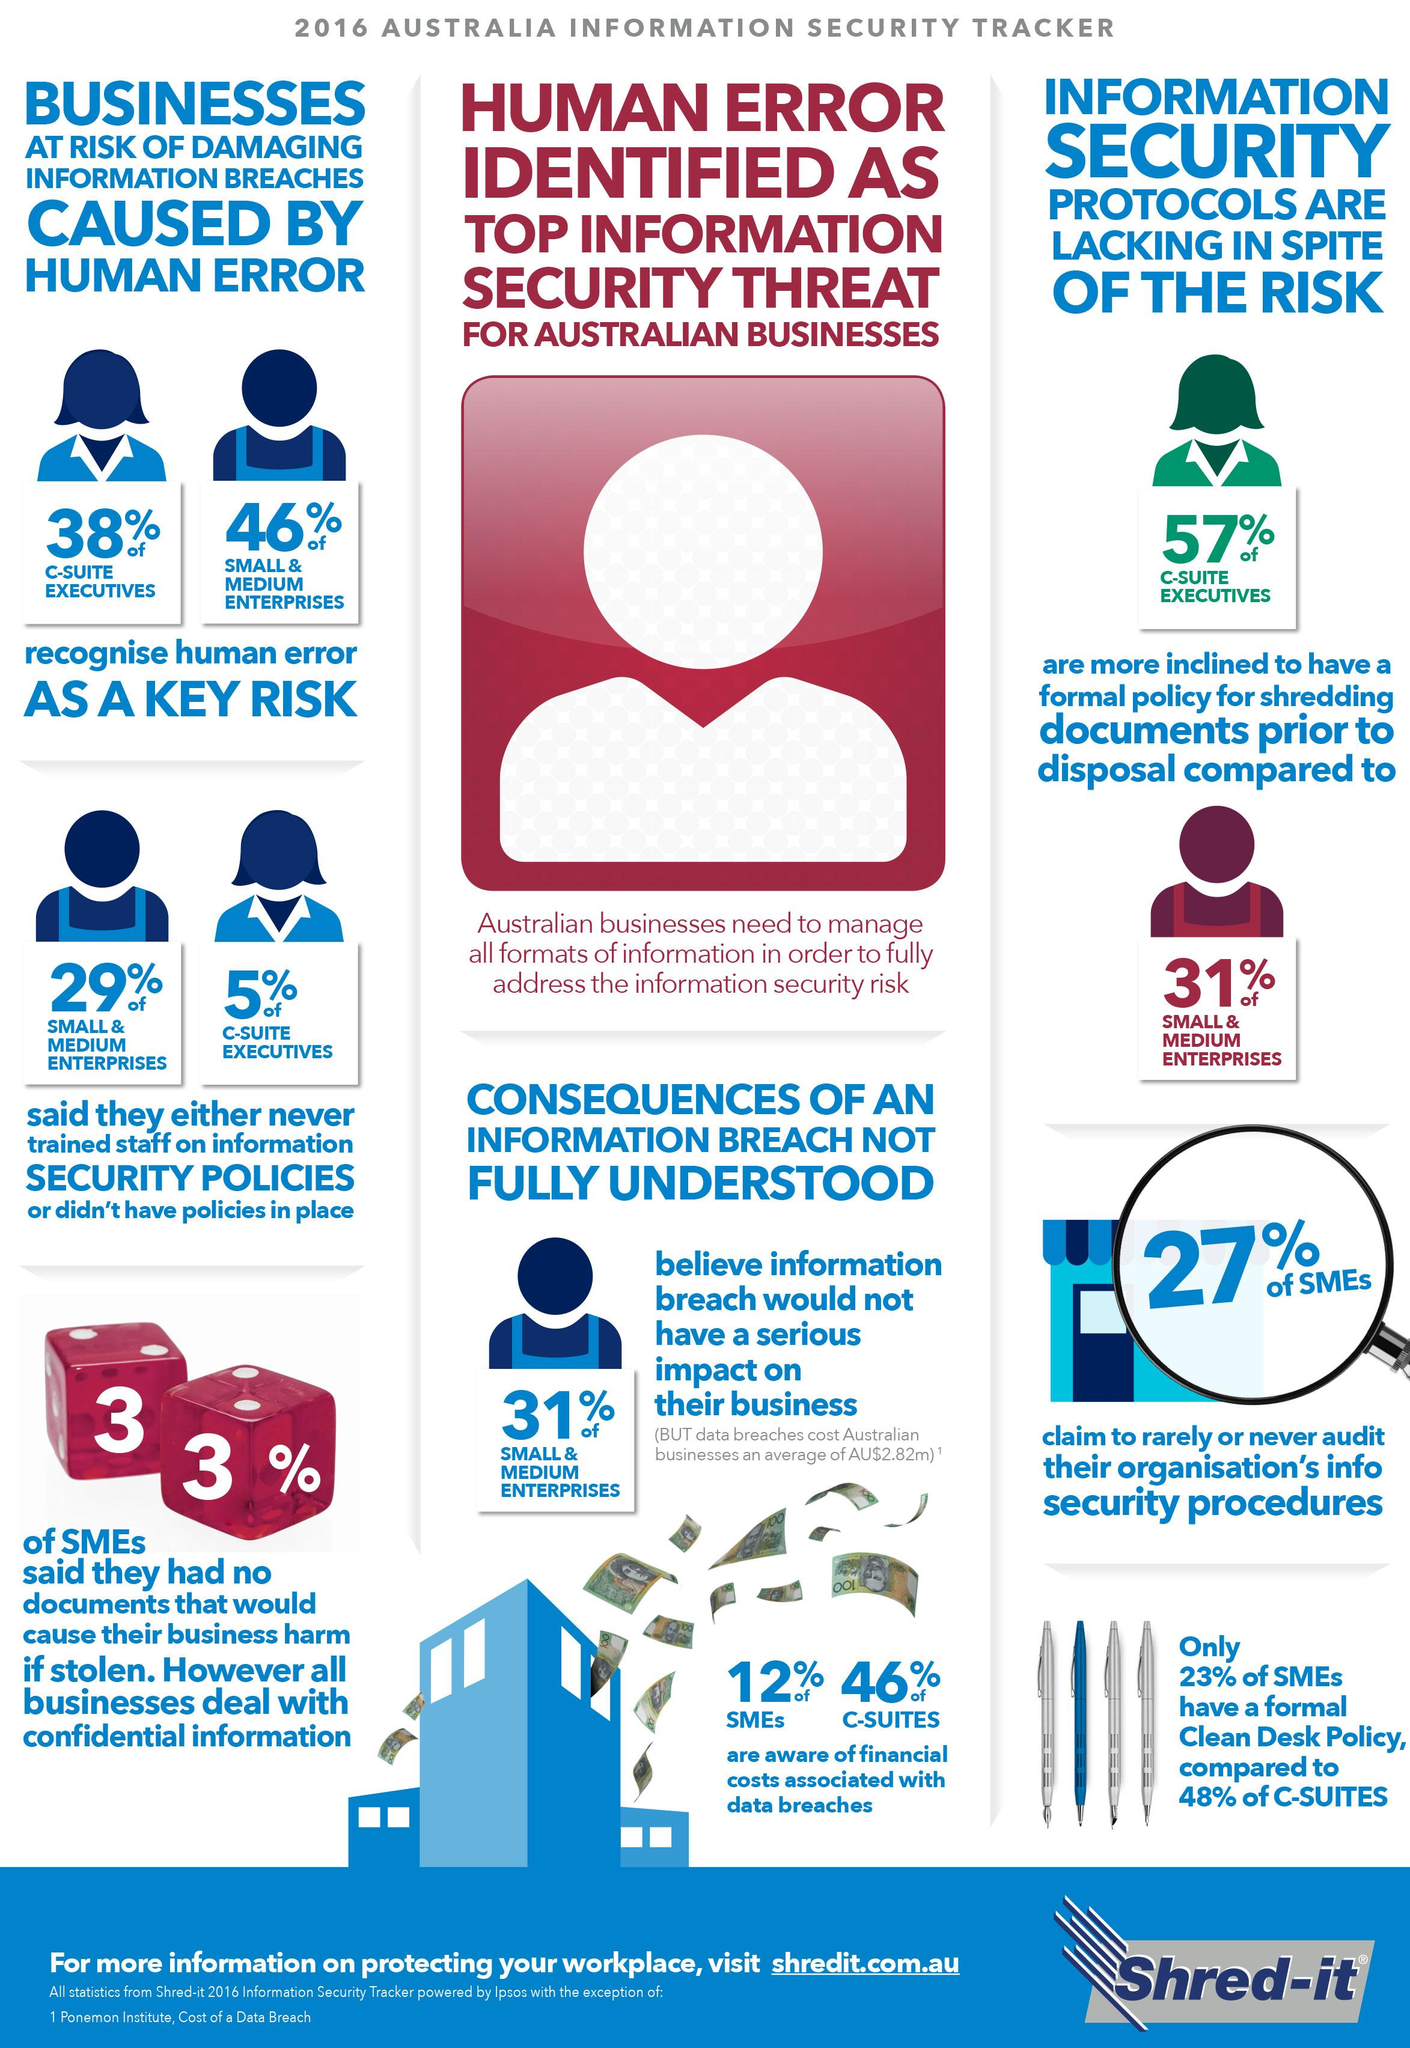Give some essential details in this illustration. In 2016, 27% of SME's in Australia claimed to rarely or never audit their organization's info security procedures. In 2016, 48% of C-Suites in Australia had a formal clean desk policy in place. According to a survey conducted in 2016, 12% of SMEs in Australia were aware of the financial costs associated with data breaches. In 2016, 62% of C-suite executives in Australia did not recognize human error as a key risk. In 2016, a significant percentage of SMEs in Australia reported that they had no documents that would cause their business harm if stolen, with 33% stating this. 